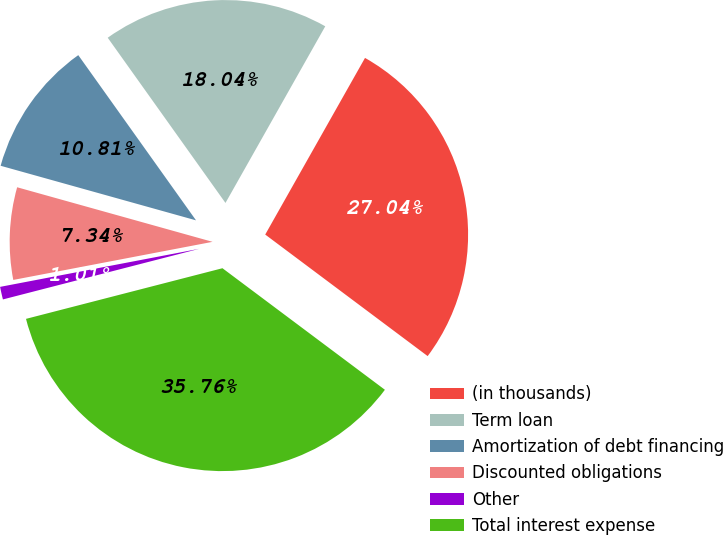Convert chart. <chart><loc_0><loc_0><loc_500><loc_500><pie_chart><fcel>(in thousands)<fcel>Term loan<fcel>Amortization of debt financing<fcel>Discounted obligations<fcel>Other<fcel>Total interest expense<nl><fcel>27.04%<fcel>18.04%<fcel>10.81%<fcel>7.34%<fcel>1.01%<fcel>35.76%<nl></chart> 